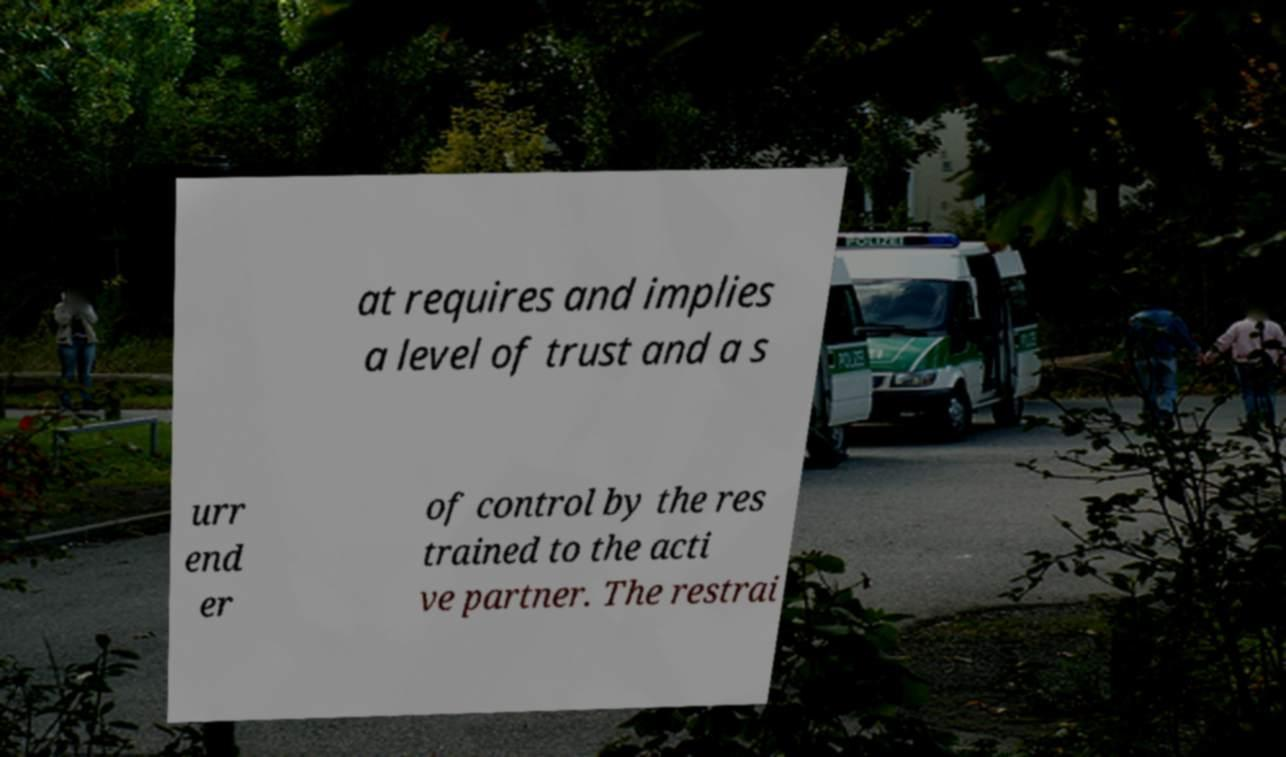Could you assist in decoding the text presented in this image and type it out clearly? at requires and implies a level of trust and a s urr end er of control by the res trained to the acti ve partner. The restrai 